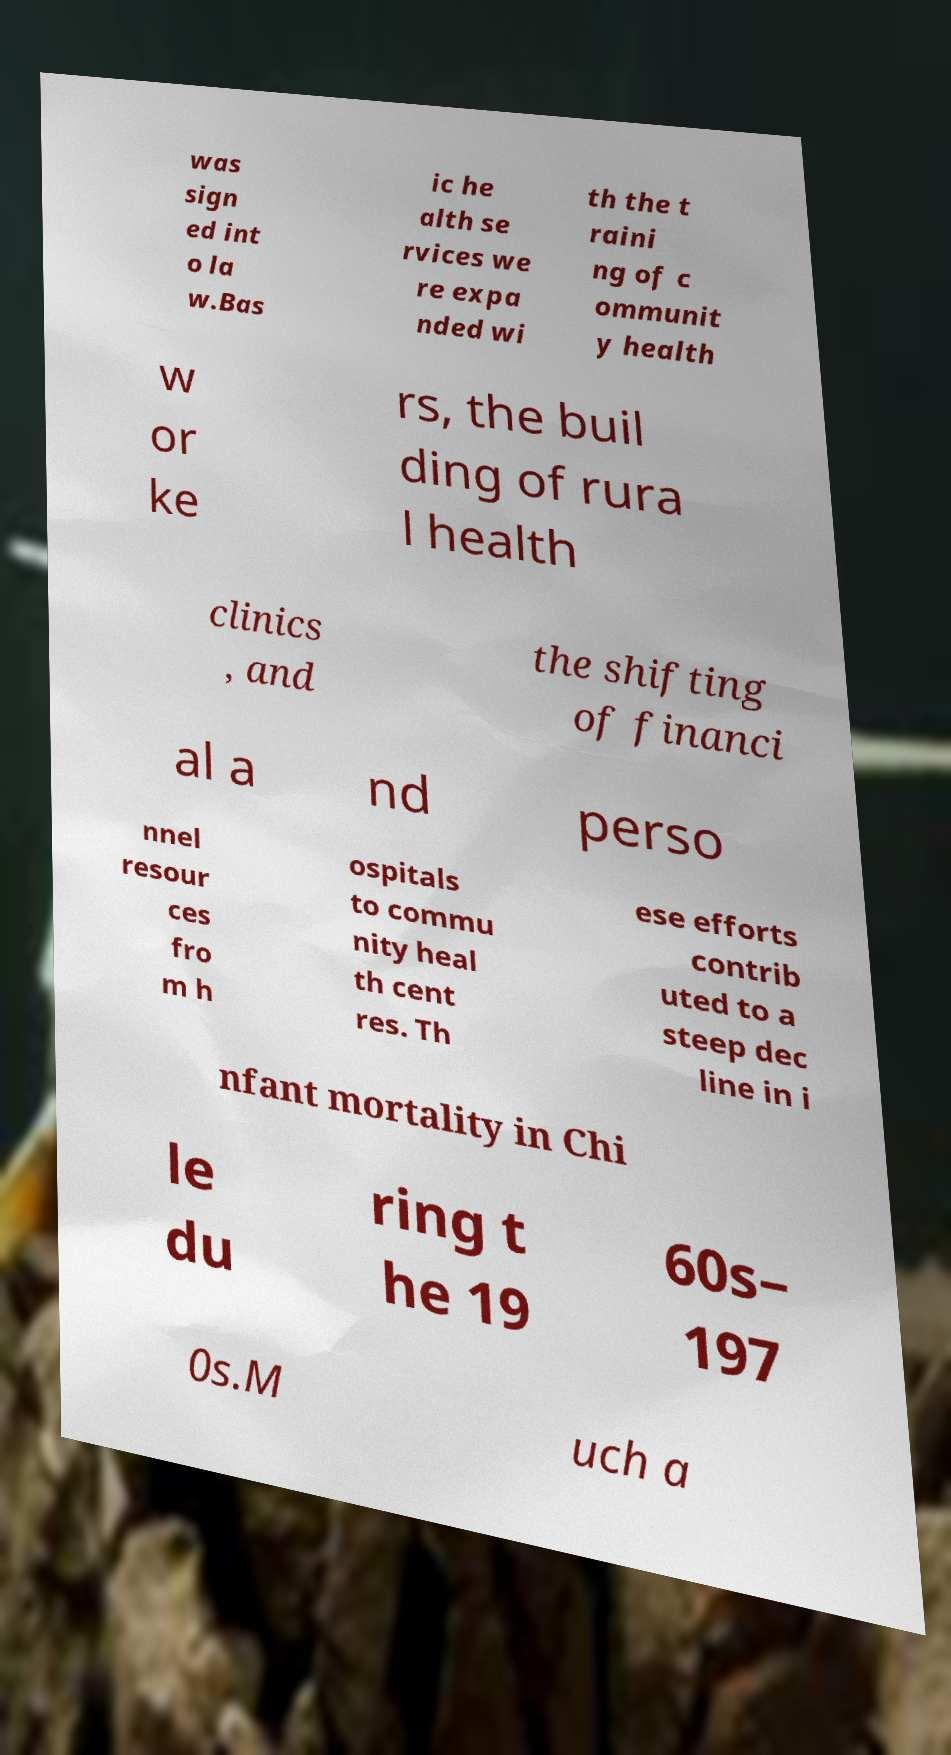Could you extract and type out the text from this image? was sign ed int o la w.Bas ic he alth se rvices we re expa nded wi th the t raini ng of c ommunit y health w or ke rs, the buil ding of rura l health clinics , and the shifting of financi al a nd perso nnel resour ces fro m h ospitals to commu nity heal th cent res. Th ese efforts contrib uted to a steep dec line in i nfant mortality in Chi le du ring t he 19 60s– 197 0s.M uch a 